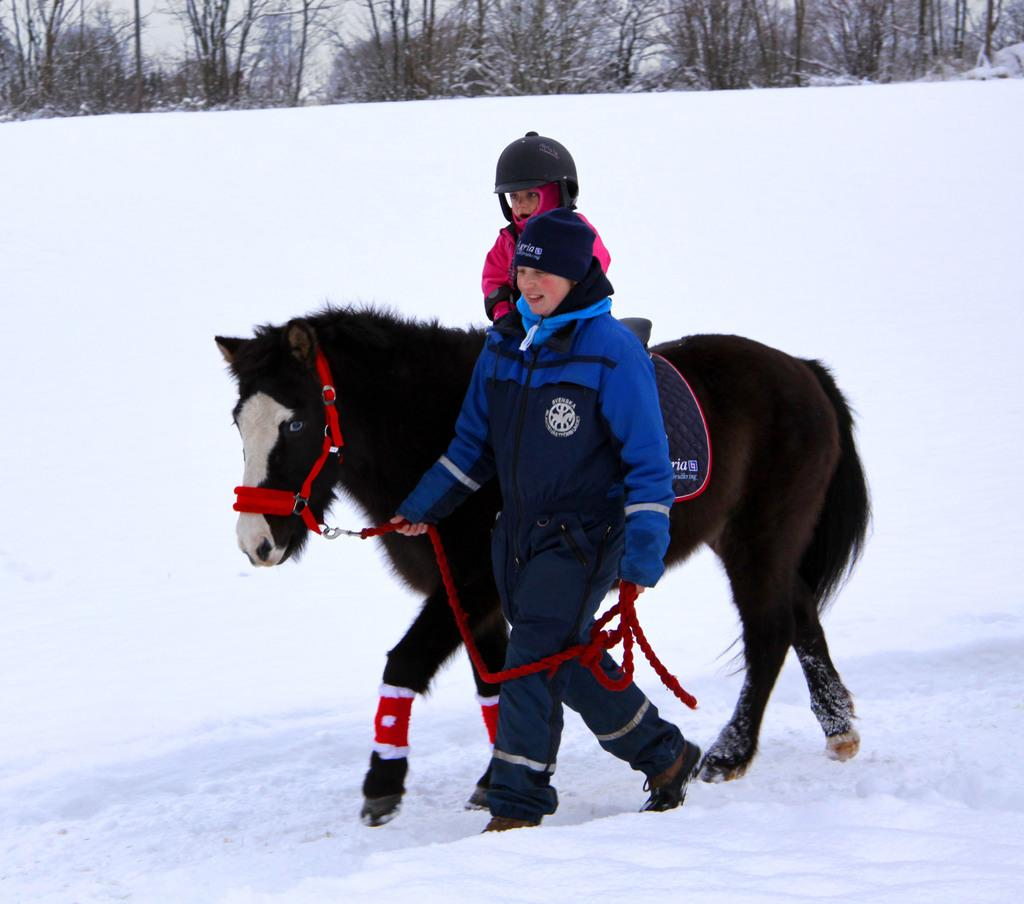What is the main subject of the image? There is a person sitting on a horse in the image. What is the color of the horse? The horse is black and white in color. Who is assisting the person on the horse? There is another person holding the horse. What type of environment is depicted in the image? There are trees visible in the image, and there is snow present. How many ladybugs can be seen on the horse in the image? There are no ladybugs present on the horse or in the image. What advice does the person holding the horse give to the rider in the image? There is no dialogue or advice given in the image; it is a static representation of the scene. 